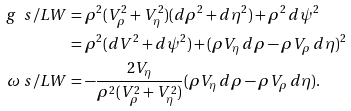<formula> <loc_0><loc_0><loc_500><loc_500>g \ s / { L W } & = \rho ^ { 2 } ( V _ { \rho } ^ { 2 } + V _ { \eta } ^ { 2 } ) ( d \rho ^ { 2 } + d \eta ^ { 2 } ) + \rho ^ { 2 } \, d \psi ^ { 2 } \\ & = \rho ^ { 2 } ( d V ^ { 2 } + d \psi ^ { 2 } ) + ( \rho V _ { \eta } \, d \rho - \rho V _ { \rho } \, d \eta ) ^ { 2 } \\ \omega \ s / { L W } & = - \frac { 2 V _ { \eta } } { \rho ^ { 2 } ( V _ { \rho } ^ { 2 } + V _ { \eta } ^ { 2 } ) } ( \rho V _ { \eta } \, d \rho - \rho V _ { \rho } \, d \eta ) .</formula> 